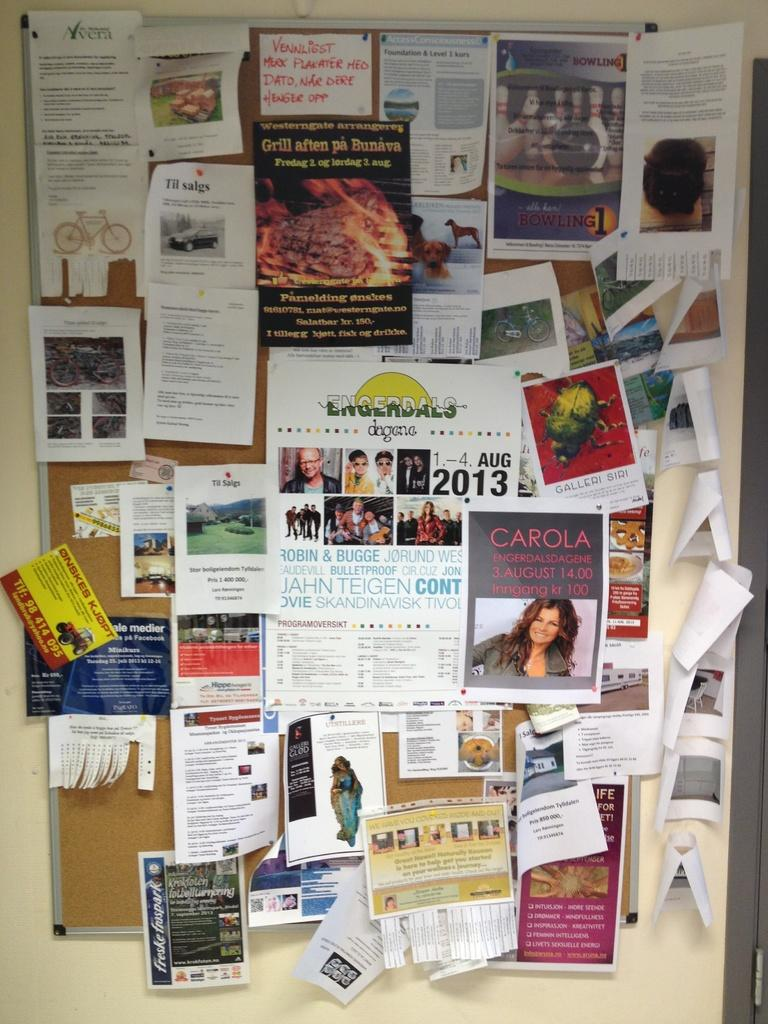Provide a one-sentence caption for the provided image. A poster for an August, 2013 event is at the center of a crowded bulletin board. 